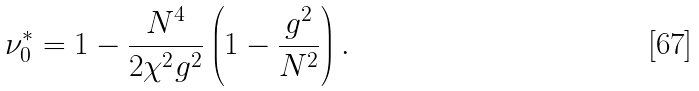<formula> <loc_0><loc_0><loc_500><loc_500>\nu ^ { * } _ { 0 } = 1 - \frac { N ^ { 4 } } { 2 \chi ^ { 2 } g ^ { 2 } } \left ( 1 - \frac { g ^ { 2 } } { N ^ { 2 } } \right ) .</formula> 